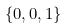<formula> <loc_0><loc_0><loc_500><loc_500>\{ 0 , 0 , 1 \}</formula> 